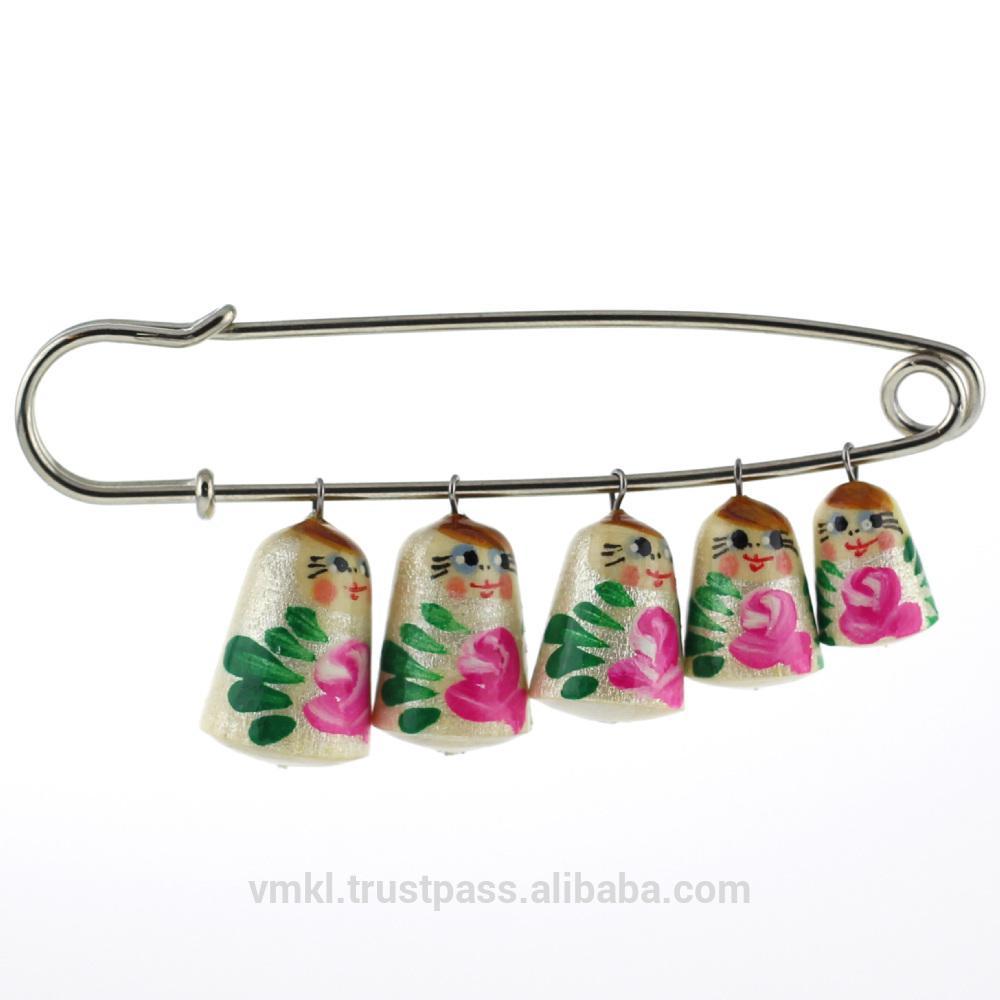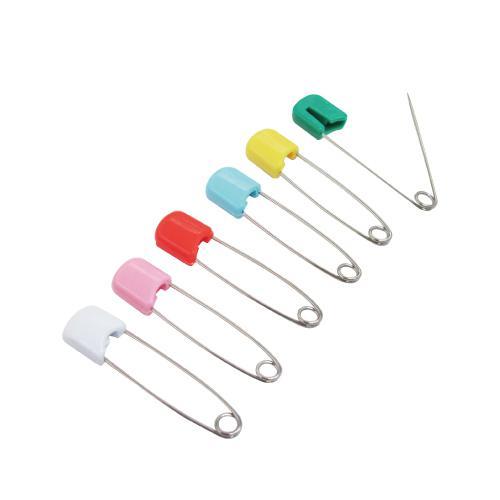The first image is the image on the left, the second image is the image on the right. For the images displayed, is the sentence "One image shows a row of six safety pins, each with a different color top, and with one of the pins open on the end" factually correct? Answer yes or no. Yes. The first image is the image on the left, the second image is the image on the right. Evaluate the accuracy of this statement regarding the images: "One of the images contains a row of safety pins and only one is open.". Is it true? Answer yes or no. Yes. 